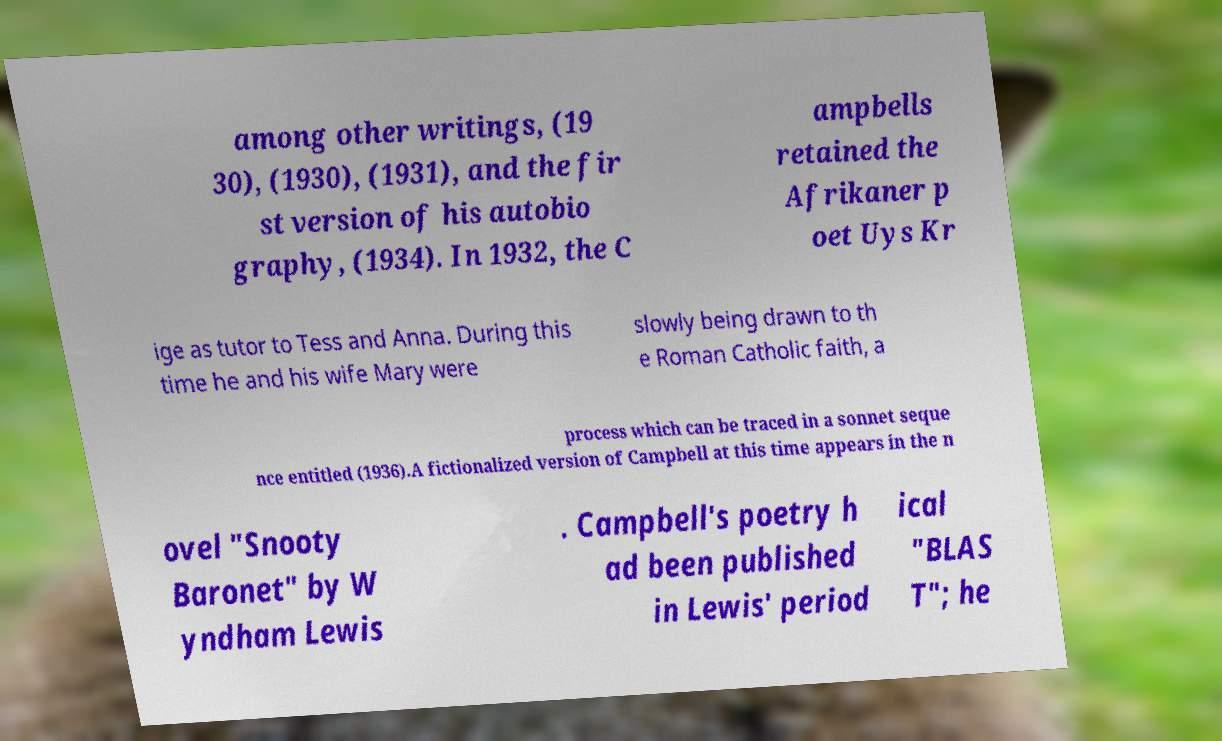I need the written content from this picture converted into text. Can you do that? among other writings, (19 30), (1930), (1931), and the fir st version of his autobio graphy, (1934). In 1932, the C ampbells retained the Afrikaner p oet Uys Kr ige as tutor to Tess and Anna. During this time he and his wife Mary were slowly being drawn to th e Roman Catholic faith, a process which can be traced in a sonnet seque nce entitled (1936).A fictionalized version of Campbell at this time appears in the n ovel "Snooty Baronet" by W yndham Lewis . Campbell's poetry h ad been published in Lewis' period ical "BLAS T"; he 